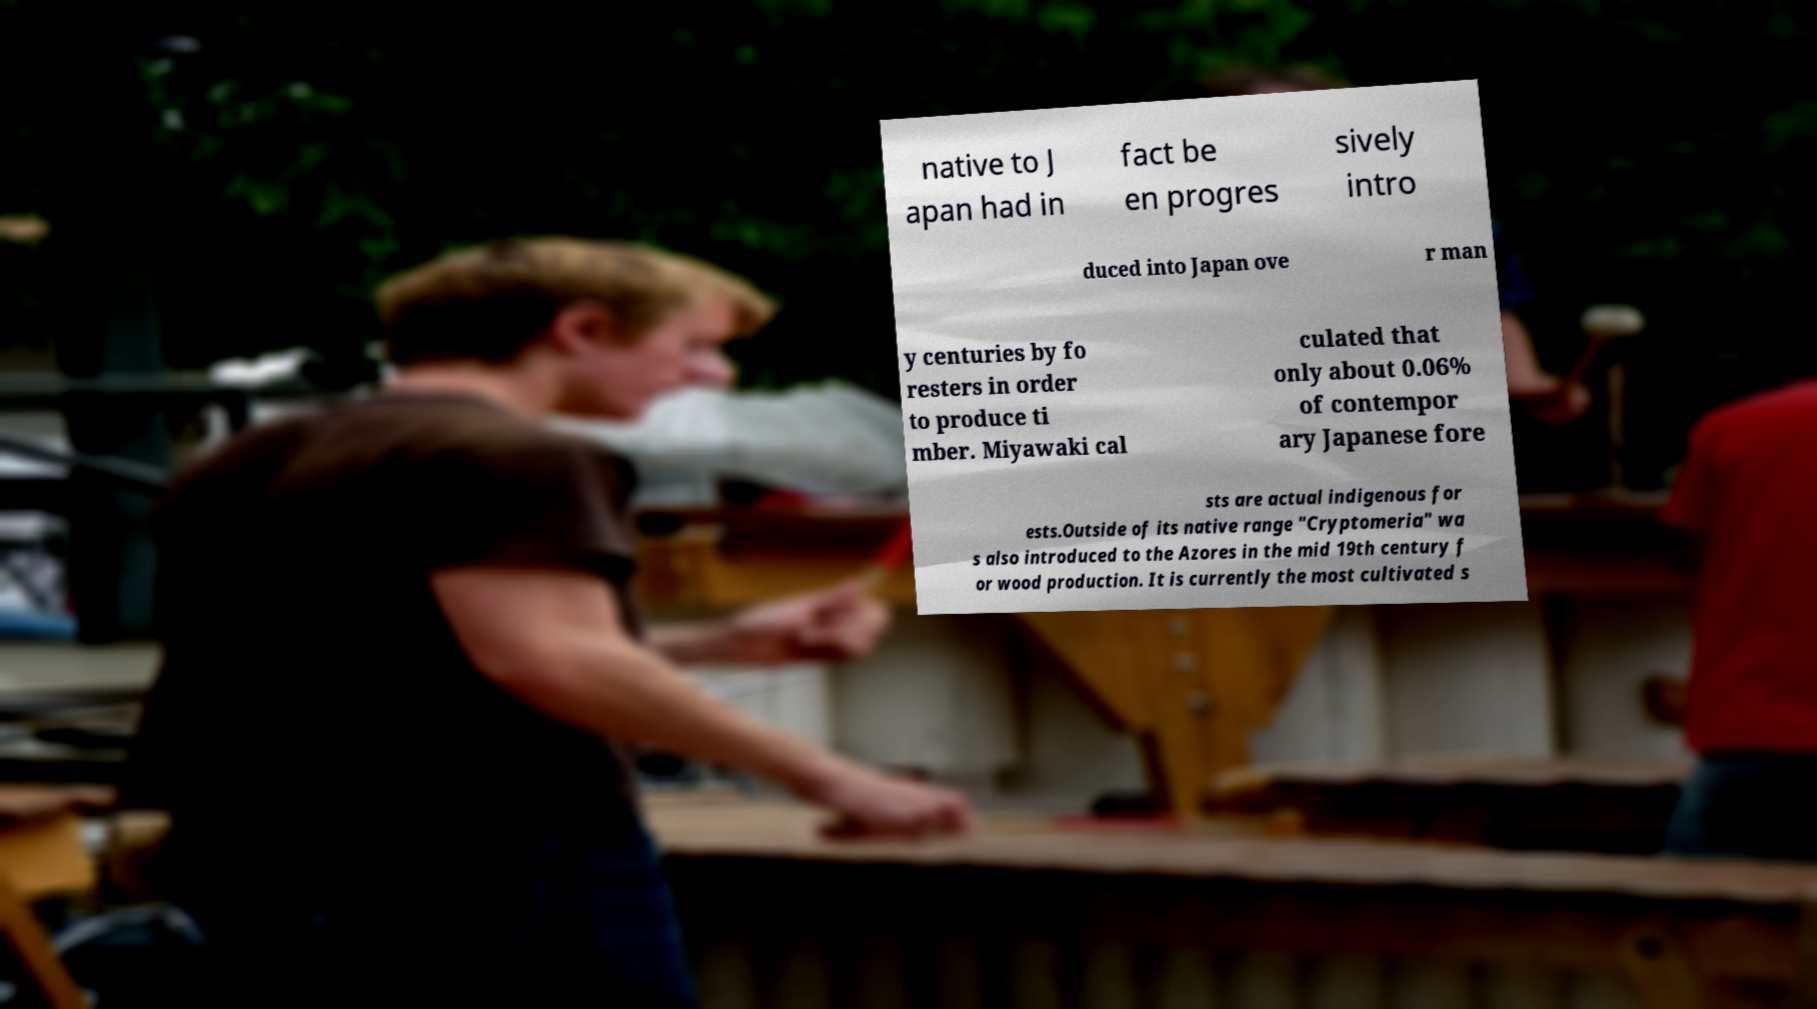Please read and relay the text visible in this image. What does it say? native to J apan had in fact be en progres sively intro duced into Japan ove r man y centuries by fo resters in order to produce ti mber. Miyawaki cal culated that only about 0.06% of contempor ary Japanese fore sts are actual indigenous for ests.Outside of its native range "Cryptomeria" wa s also introduced to the Azores in the mid 19th century f or wood production. It is currently the most cultivated s 